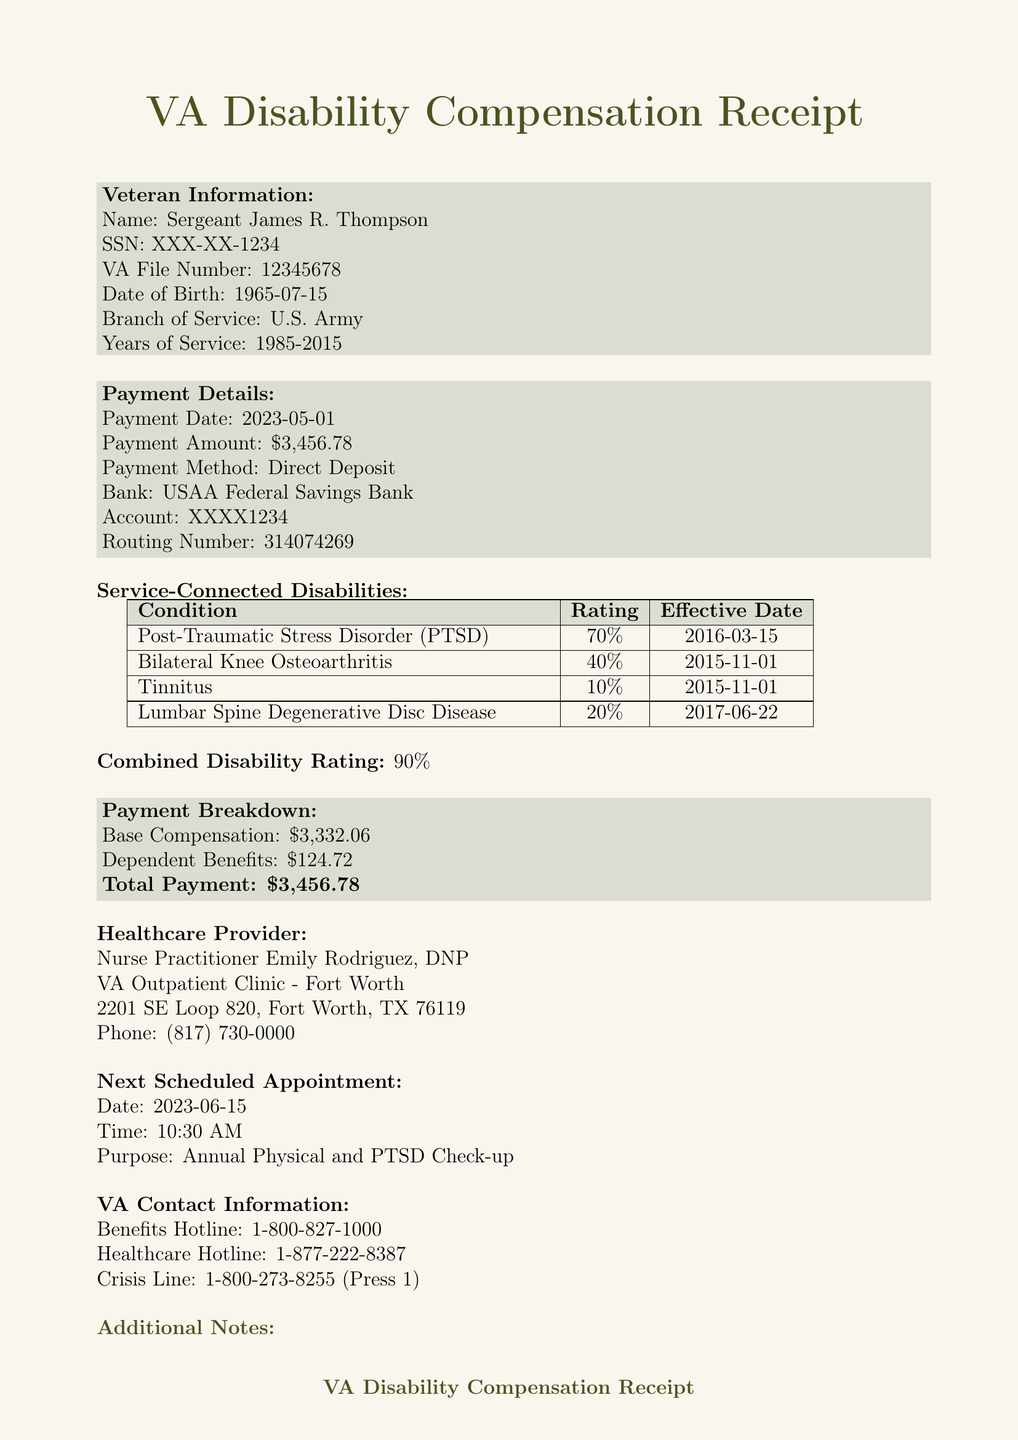What is the name of the veteran? The receipt provides the veteran's name as Sergeant James R. Thompson.
Answer: Sergeant James R. Thompson What is the payment date? The document specifies that the payment was made on May 1, 2023.
Answer: 2023-05-01 What is the total payment amount? The total payment amount is clearly stated in the document as $3,456.78.
Answer: $3,456.78 What is the combined disability rating? The combined disability rating is highlighted in the document and is stated as 90%.
Answer: 90% How many disabilities are listed in the document? The document lists four service-connected disabilities in total.
Answer: Four What is the effective date of the PTSD rating? The effective date for PTSD, as noted, is March 15, 2016.
Answer: 2016-03-15 Who is the healthcare provider? The document identifies Nurse Practitioner Emily Rodriguez as the healthcare provider.
Answer: Nurse Practitioner Emily Rodriguez What is the next appointment date? The next scheduled appointment is set for June 15, 2023.
Answer: 2023-06-15 What is the purpose of the next appointment? The document mentions that the purpose of the next appointment is for an Annual Physical and PTSD Check-up.
Answer: Annual Physical and PTSD Check-up 